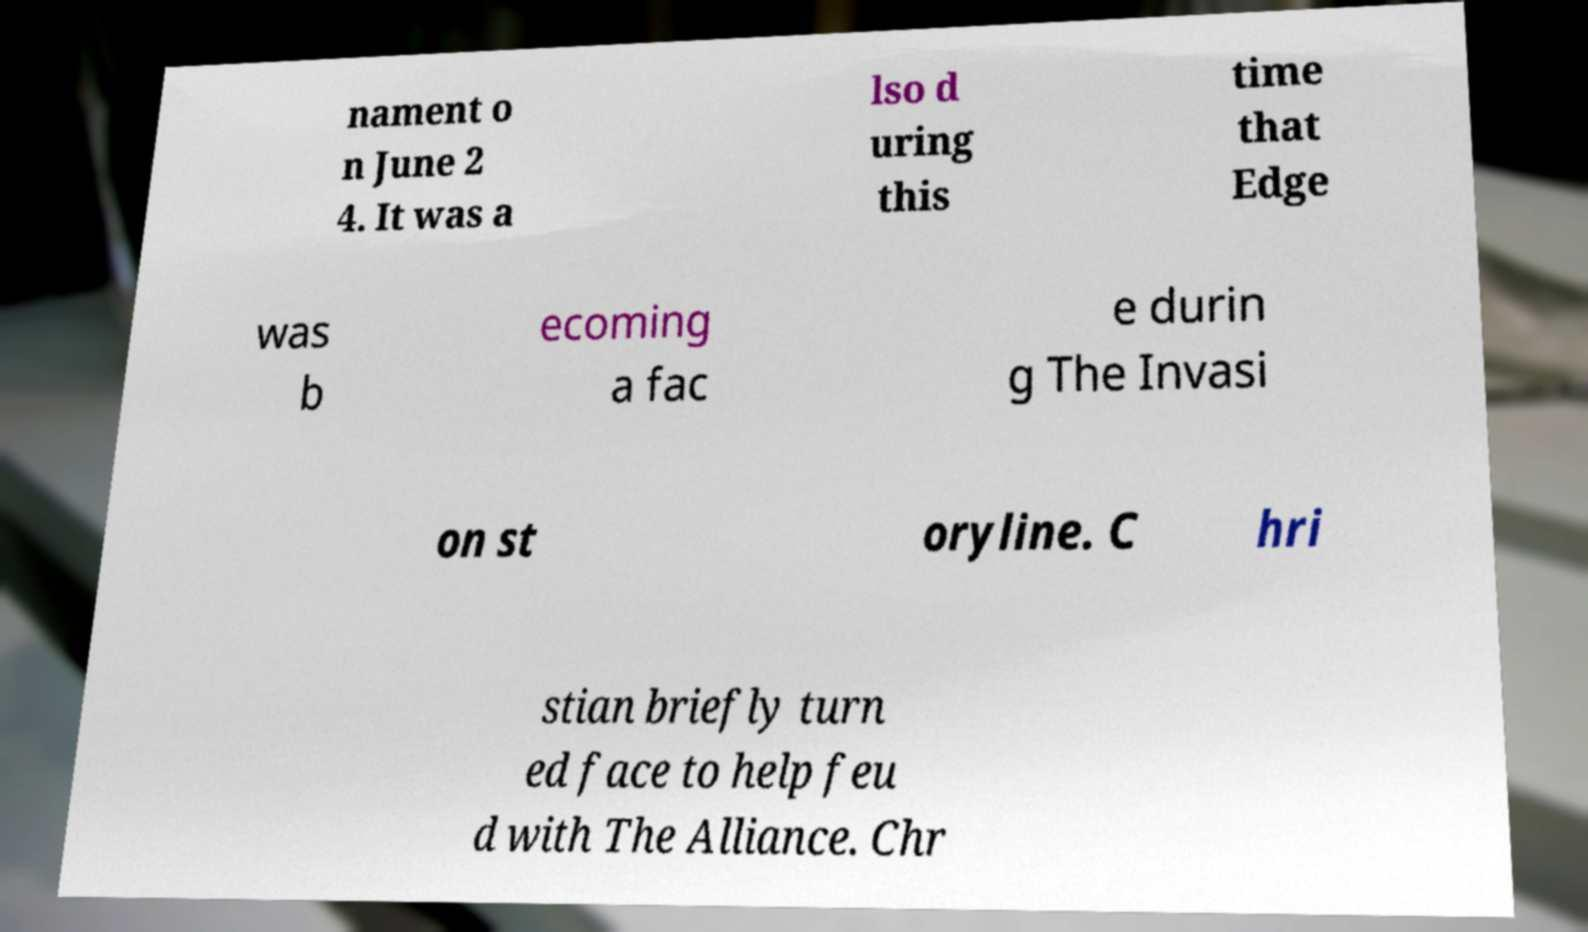For documentation purposes, I need the text within this image transcribed. Could you provide that? nament o n June 2 4. It was a lso d uring this time that Edge was b ecoming a fac e durin g The Invasi on st oryline. C hri stian briefly turn ed face to help feu d with The Alliance. Chr 